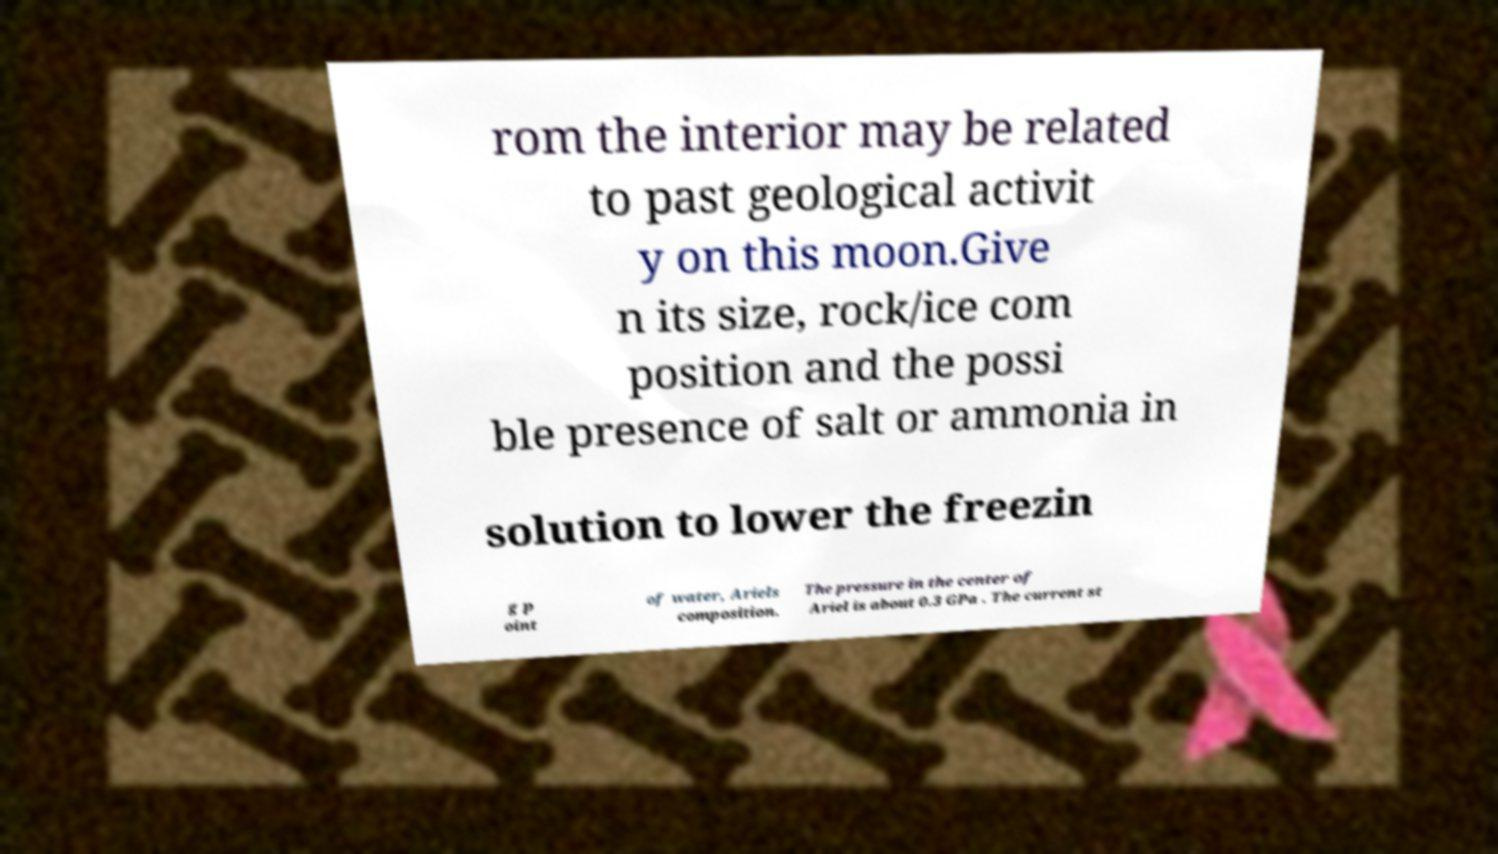Please read and relay the text visible in this image. What does it say? rom the interior may be related to past geological activit y on this moon.Give n its size, rock/ice com position and the possi ble presence of salt or ammonia in solution to lower the freezin g p oint of water, Ariels composition. The pressure in the center of Ariel is about 0.3 GPa . The current st 